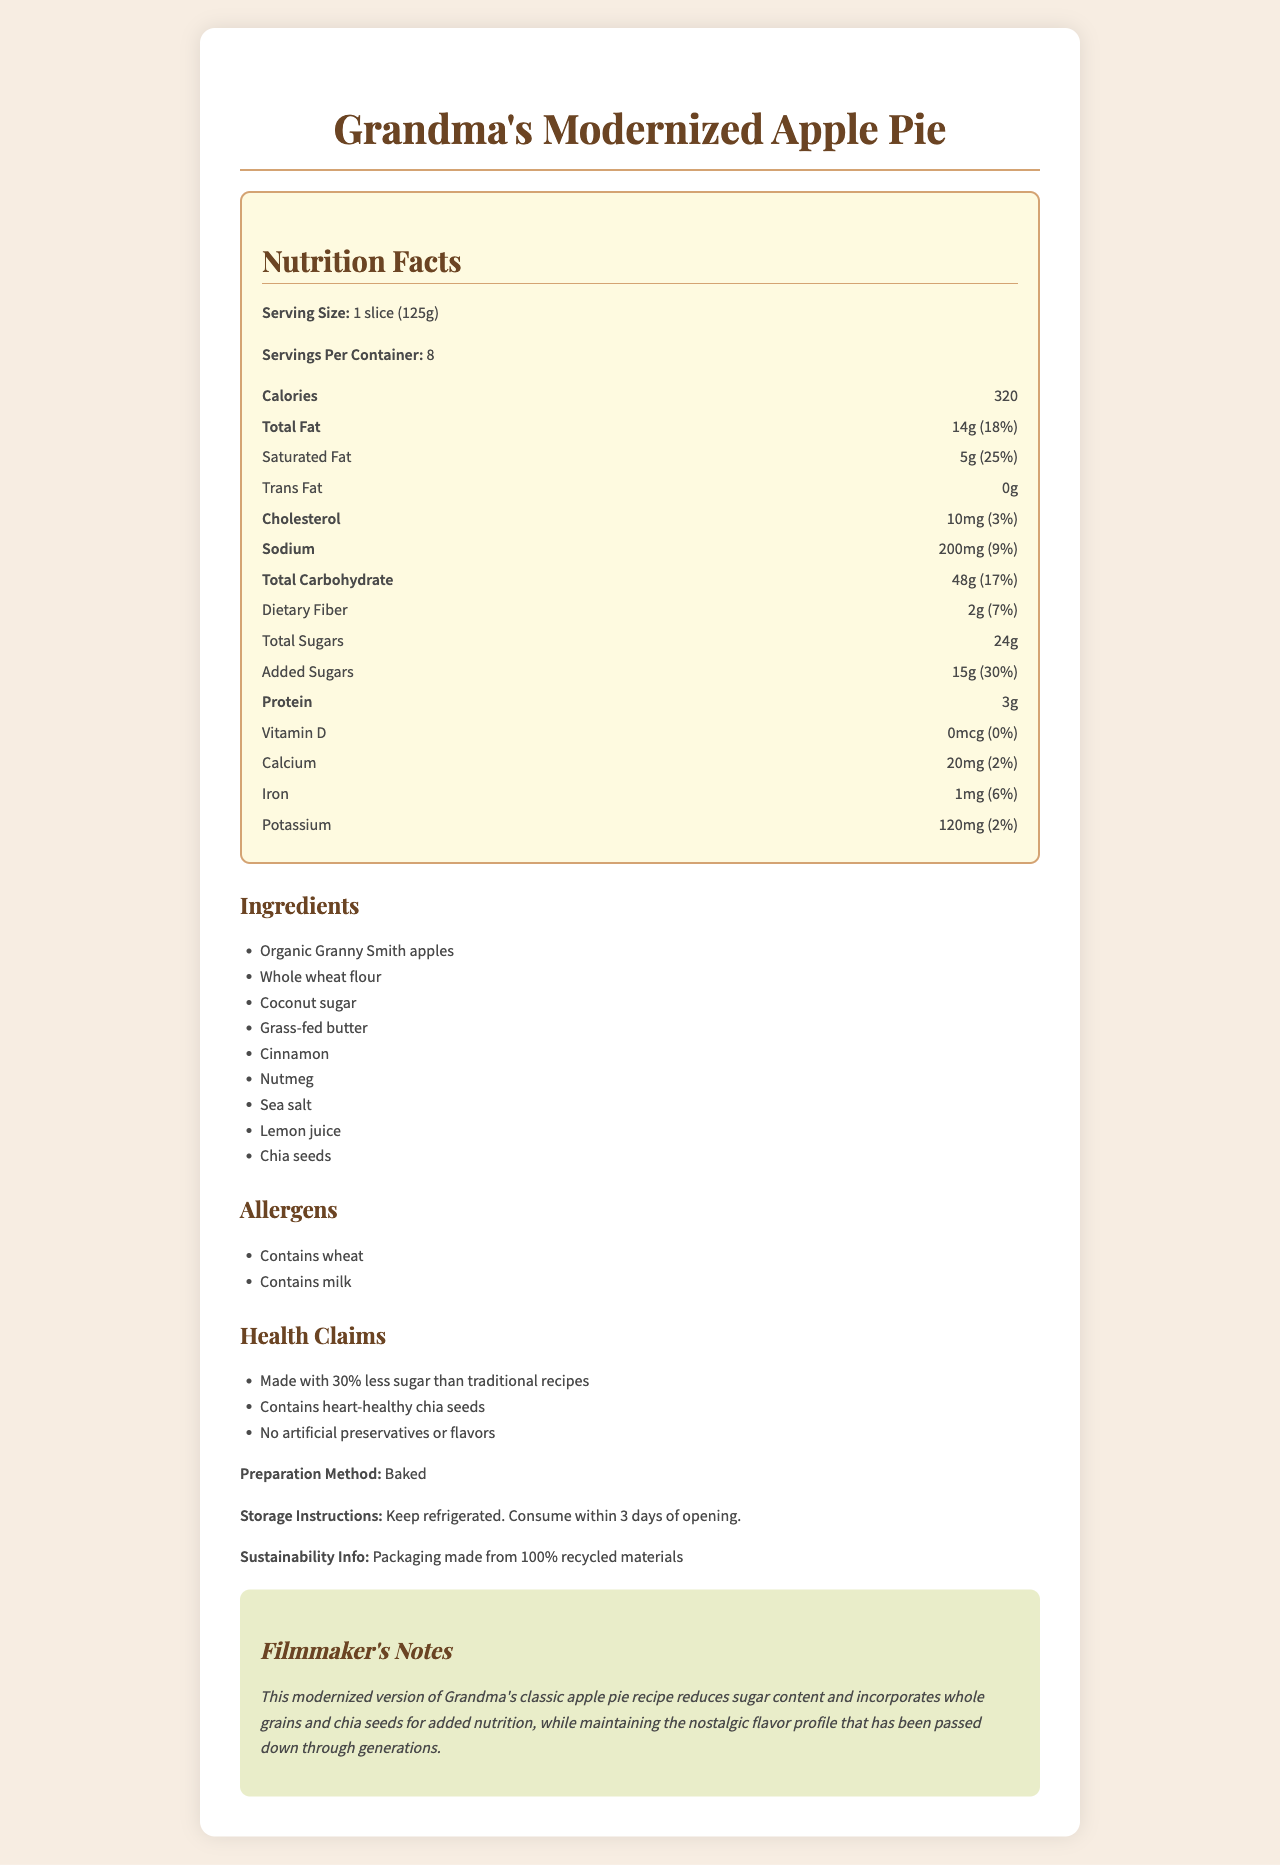what is the serving size? The serving size is listed at the beginning of the Nutrition Facts section.
Answer: 1 slice (125g) how many servings per container are there? The "Servings Per Container" is mentioned right below the serving size in the Nutrition Facts section.
Answer: 8 how many calories are there per serving? The calorie content per serving is displayed prominently under the title "Calories" in the Nutrition Facts section.
Answer: 320 what is the total fat content per serving? The total fat content is listed as "Total Fat" with the amount of 14g in the Nutrition Facts section.
Answer: 14g how much added sugar is in one serving? The "Added Sugars" section lists the amount as 15g.
Answer: 15g how much protein does one serving contain? The amount of protein per serving is listed at the end of the Nutrition Facts section as 3g.
Answer: 3g which of these ingredients is not included in the pie? A. Coconut sugar B. Almond milk C. Lemon juice D. Chia seeds The list of ingredients includes Coconut sugar, Lemon juice, and Chia seeds but does not mention Almond milk.
Answer: B. Almond milk what percentage of the daily value of saturated fat does one serving provide? The daily value percentage for Saturated Fat is listed as 25% in the Nutrition Facts section.
Answer: 25% does this apple pie contain any artificial preservatives or flavors? The health claims section states "No artificial preservatives or flavors."
Answer: No was the pie baked or fried? The preparation method specified is "Baked."
Answer: Baked which nutrient has the highest daily value percentage? A. Total Fat B. Added Sugars C. Iron D. Sodium Added Sugars have a daily value percentage of 30%, which is higher than Total Fat (18%), Iron (6%), and Sodium (9%).
Answer: B. Added Sugars how many milligrams of sodium are in one serving? The sodium content per serving is listed as 200mg.
Answer: 200mg can you consume this pie if you have a wheat allergy? The allergens section states "Contains wheat."
Answer: No what are the main health benefits highlighted in the product? The health claims section mentions "Made with 30% less sugar than traditional recipes," "Contains heart-healthy chia seeds," and "No artificial preservatives or flavors."
Answer: Less sugar, heart-healthy chia seeds, no artificial preservatives how soon should you consume the pie after opening? The storage instructions specify to consume within 3 days of opening.
Answer: Within 3 days what type of flour is used in the pie? The list of ingredients mentions "Whole wheat flour."
Answer: Whole wheat flour how much vitamin D is in one serving? The Nutrition Facts section shows 0mcg for Vitamin D.
Answer: 0mcg describe the overall information provided in this document. The document covers nutritional details, ingredients, allergens, health claims, preparation method, storage instructions, and sustainability, emphasizing the modernization of a nostalgic recipe.
Answer: The document provides detailed nutritional information about "Grandma's Modernized Apple Pie," including serving size, calories, fat content, sugars, and other nutrients. It lists ingredients, allergens, and health claims, such as reduced sugar content and inclusion of chia seeds. Additionally, there are notes on preparation, storage, and sustainability, mentioning recycled packaging and instructions for refrigerated storage. Filmmaker's notes highlight the modernization of a classic family recipe while maintaining its traditional flavor. is the packaging of the pie made from new materials? The sustainability info mentions that the packaging is made from 100% recycled materials.
Answer: No how many grams of total carbohydrates are there per serving? The total carbohydrate content per serving is listed as 48g in the Nutrition Facts section.
Answer: 48g what kind of apples are used in the pie? The ingredients list mentions "Organic Granny Smith apples."
Answer: Organic Granny Smith apples how is the pie aligned with sustainability practices? The sustainability info states that the packaging is made from 100% recycled materials.
Answer: Using 100% recycled packaging how much calcium is in one serving? The amount of calcium per serving is listed as 20mg.
Answer: 20mg are there any artificial colors in the pie? The document does not mention anything about artificial colors, only about artificial preservatives and flavors.
Answer: Cannot be determined 